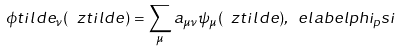Convert formula to latex. <formula><loc_0><loc_0><loc_500><loc_500>\phi t i l d e _ { \nu } ( \ z t i l d e ) = \sum _ { \mu } a _ { \mu \nu } \psi _ { \mu } ( \ z t i l d e ) , \ e l a b e l { p h i _ { p } s i }</formula> 